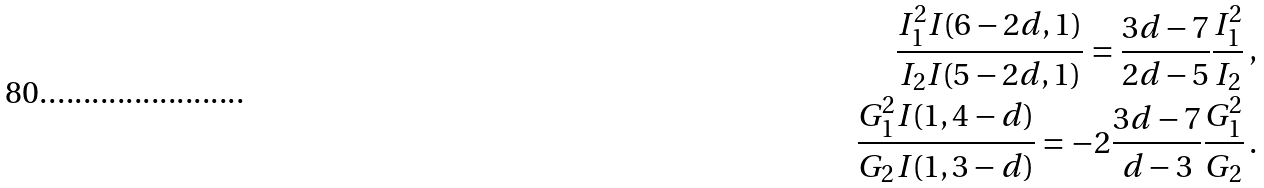Convert formula to latex. <formula><loc_0><loc_0><loc_500><loc_500>\frac { I _ { 1 } ^ { 2 } I ( 6 - 2 d , 1 ) } { I _ { 2 } I ( 5 - 2 d , 1 ) } = \frac { 3 d - 7 } { 2 d - 5 } \frac { I _ { 1 } ^ { 2 } } { I _ { 2 } } \, , \\ \frac { G _ { 1 } ^ { 2 } I ( 1 , 4 - d ) } { G _ { 2 } I ( 1 , 3 - d ) } = - 2 \frac { 3 d - 7 } { d - 3 } \frac { G _ { 1 } ^ { 2 } } { G _ { 2 } } \, .</formula> 